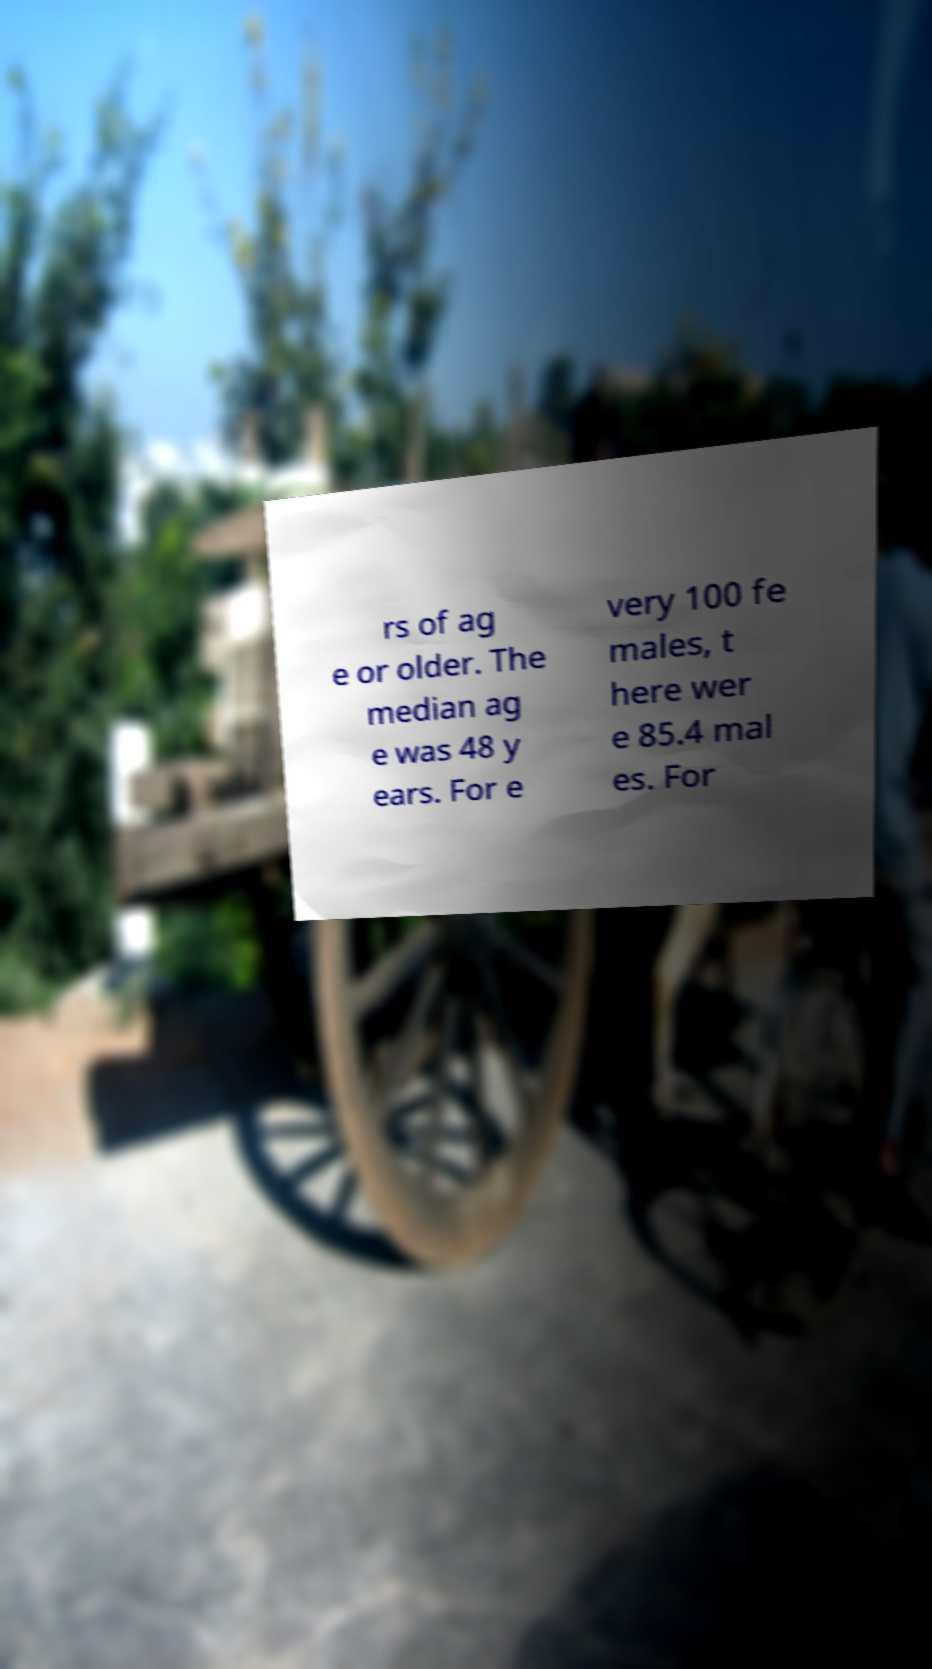What messages or text are displayed in this image? I need them in a readable, typed format. rs of ag e or older. The median ag e was 48 y ears. For e very 100 fe males, t here wer e 85.4 mal es. For 